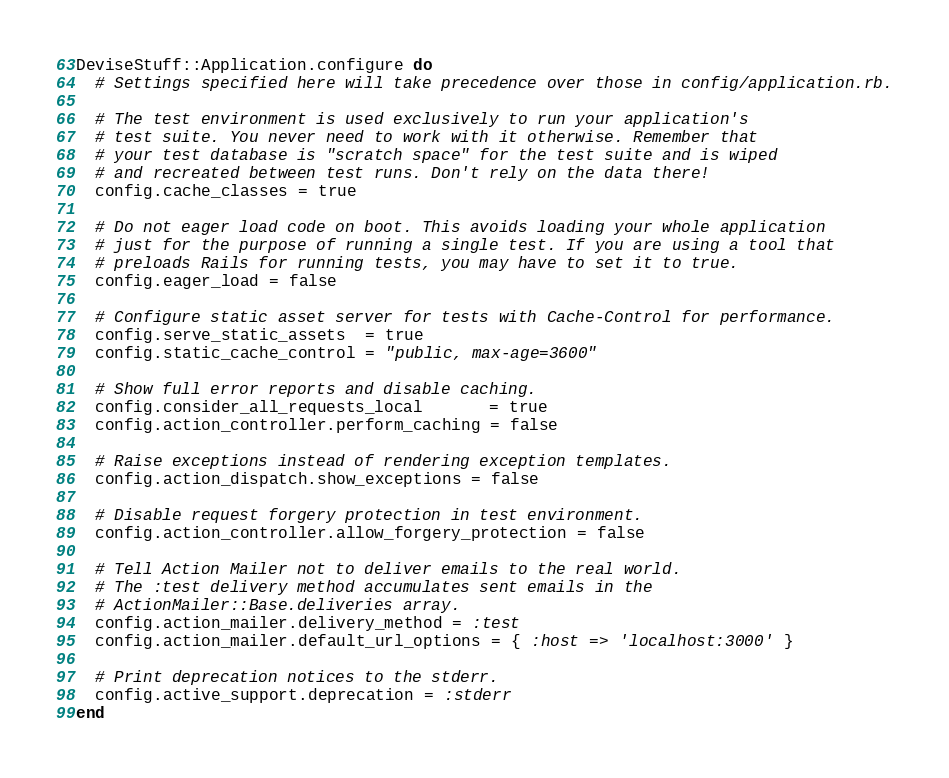<code> <loc_0><loc_0><loc_500><loc_500><_Ruby_>DeviseStuff::Application.configure do
  # Settings specified here will take precedence over those in config/application.rb.

  # The test environment is used exclusively to run your application's
  # test suite. You never need to work with it otherwise. Remember that
  # your test database is "scratch space" for the test suite and is wiped
  # and recreated between test runs. Don't rely on the data there!
  config.cache_classes = true

  # Do not eager load code on boot. This avoids loading your whole application
  # just for the purpose of running a single test. If you are using a tool that
  # preloads Rails for running tests, you may have to set it to true.
  config.eager_load = false

  # Configure static asset server for tests with Cache-Control for performance.
  config.serve_static_assets  = true
  config.static_cache_control = "public, max-age=3600"

  # Show full error reports and disable caching.
  config.consider_all_requests_local       = true
  config.action_controller.perform_caching = false

  # Raise exceptions instead of rendering exception templates.
  config.action_dispatch.show_exceptions = false

  # Disable request forgery protection in test environment.
  config.action_controller.allow_forgery_protection = false

  # Tell Action Mailer not to deliver emails to the real world.
  # The :test delivery method accumulates sent emails in the
  # ActionMailer::Base.deliveries array.
  config.action_mailer.delivery_method = :test
  config.action_mailer.default_url_options = { :host => 'localhost:3000' }

  # Print deprecation notices to the stderr.
  config.active_support.deprecation = :stderr
end
</code> 